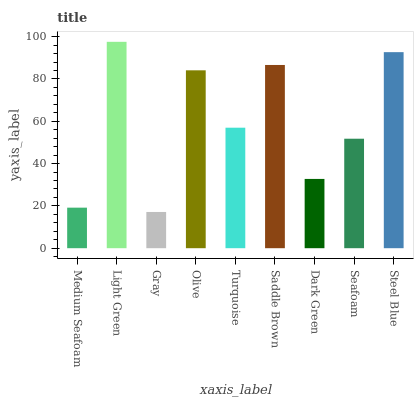Is Gray the minimum?
Answer yes or no. Yes. Is Light Green the maximum?
Answer yes or no. Yes. Is Light Green the minimum?
Answer yes or no. No. Is Gray the maximum?
Answer yes or no. No. Is Light Green greater than Gray?
Answer yes or no. Yes. Is Gray less than Light Green?
Answer yes or no. Yes. Is Gray greater than Light Green?
Answer yes or no. No. Is Light Green less than Gray?
Answer yes or no. No. Is Turquoise the high median?
Answer yes or no. Yes. Is Turquoise the low median?
Answer yes or no. Yes. Is Gray the high median?
Answer yes or no. No. Is Medium Seafoam the low median?
Answer yes or no. No. 